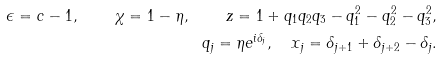<formula> <loc_0><loc_0><loc_500><loc_500>\epsilon = c - 1 , \quad \chi = 1 - \eta , \quad z = 1 + q _ { 1 } q _ { 2 } q _ { 3 } - q _ { 1 } ^ { 2 } - q _ { 2 } ^ { 2 } - q _ { 3 } ^ { 2 } , \\ q _ { j } = \eta e ^ { i \delta _ { j } } , \quad x _ { j } = \delta _ { j + 1 } + \delta _ { j + 2 } - \delta _ { j } .</formula> 